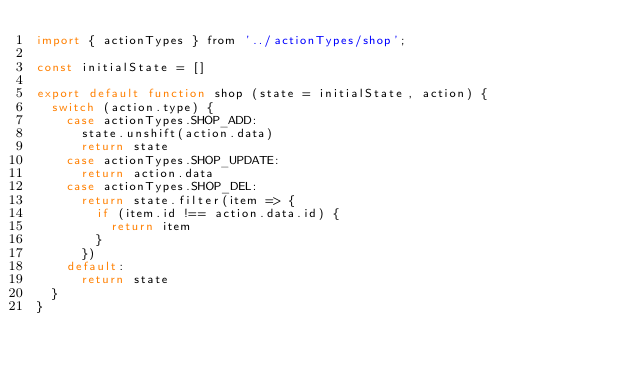Convert code to text. <code><loc_0><loc_0><loc_500><loc_500><_JavaScript_>import { actionTypes } from '../actionTypes/shop';

const initialState = []

export default function shop (state = initialState, action) {
  switch (action.type) {
    case actionTypes.SHOP_ADD:
      state.unshift(action.data)
      return state
    case actionTypes.SHOP_UPDATE:
      return action.data
    case actionTypes.SHOP_DEL:
      return state.filter(item => {
        if (item.id !== action.data.id) {
          return item
        }
      })
    default:
      return state
  }
}
</code> 